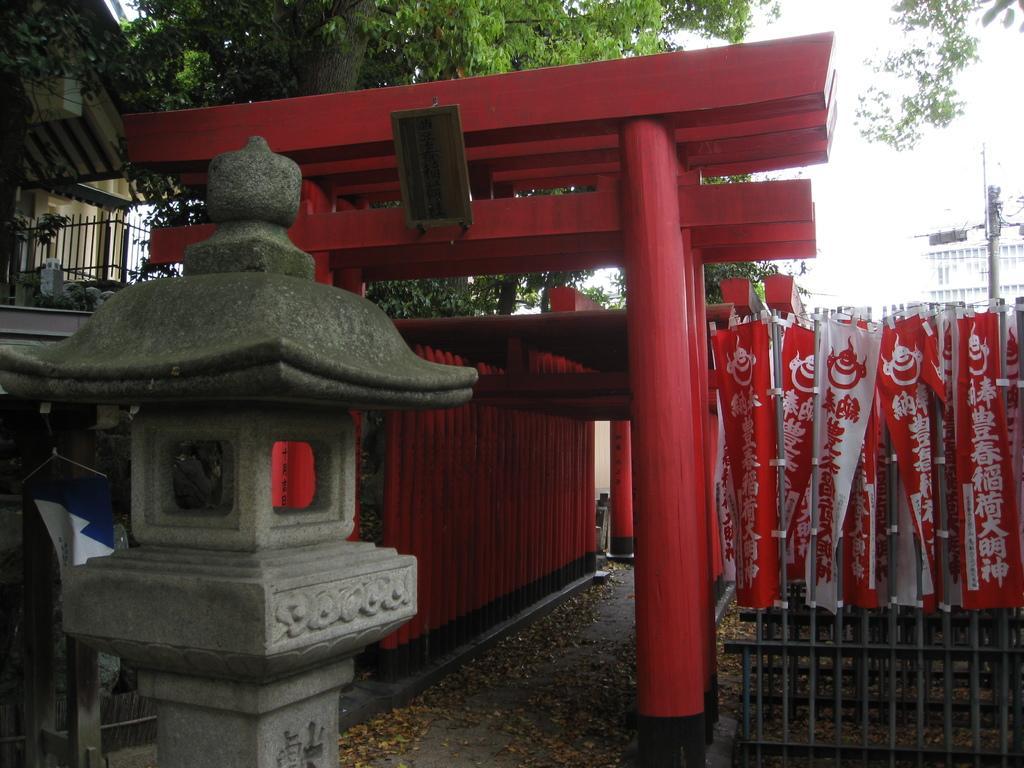How would you summarize this image in a sentence or two? In this image I can see a stone pole in the front. In the background I can see few red colour pillars, few trees and few buildings. On the right side of the image I can see the iron bars, a pole, few colourful things and on it something is written. On the top left side of the image I can see the iron fence. 